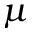<formula> <loc_0><loc_0><loc_500><loc_500>\mu</formula> 